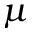<formula> <loc_0><loc_0><loc_500><loc_500>\mu</formula> 